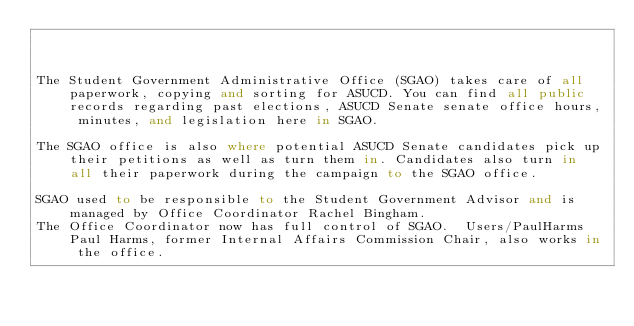<code> <loc_0><loc_0><loc_500><loc_500><_FORTRAN_>


The Student Government Administrative Office (SGAO) takes care of all paperwork, copying and sorting for ASUCD. You can find all public records regarding past elections, ASUCD Senate senate office hours, minutes, and legislation here in SGAO.

The SGAO office is also where potential ASUCD Senate candidates pick up their petitions as well as turn them in. Candidates also turn in all their paperwork during the campaign to the SGAO office.

SGAO used to be responsible to the Student Government Advisor and is managed by Office Coordinator Rachel Bingham.
The Office Coordinator now has full control of SGAO.  Users/PaulHarms Paul Harms, former Internal Affairs Commission Chair, also works in the office.
</code> 